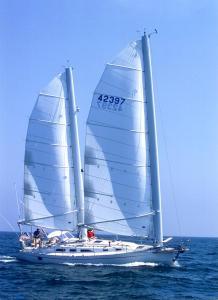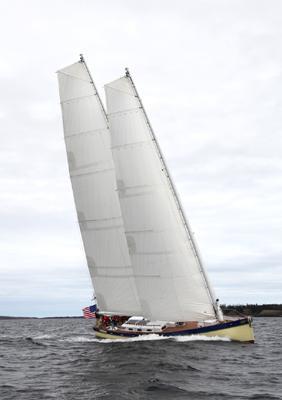The first image is the image on the left, the second image is the image on the right. For the images displayed, is the sentence "All the boats are heading in the same direction." factually correct? Answer yes or no. Yes. 